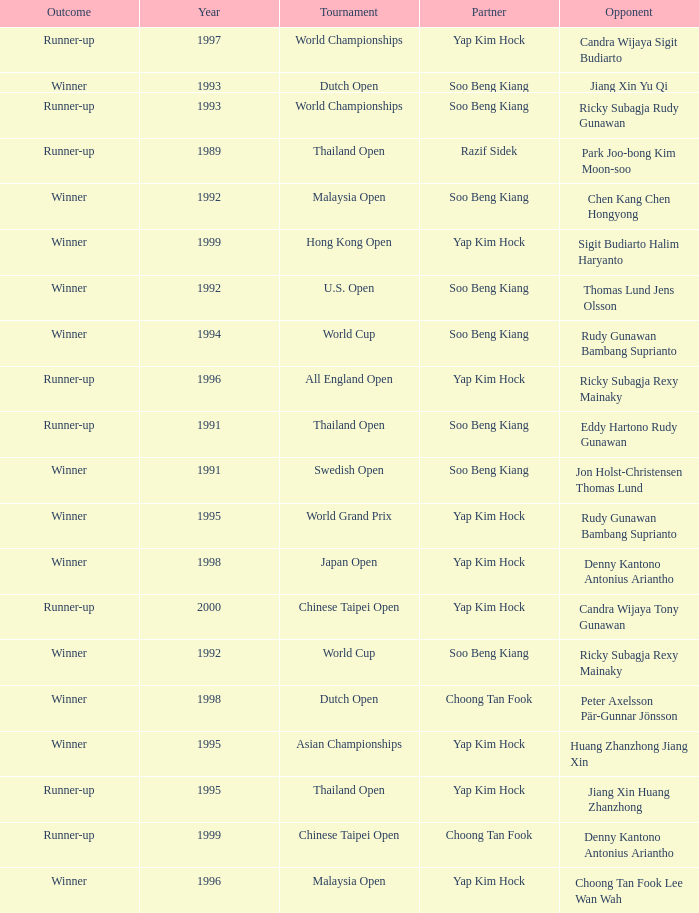Who was Choong Tan Fook's opponent in 1999? Denny Kantono Antonius Ariantho. 